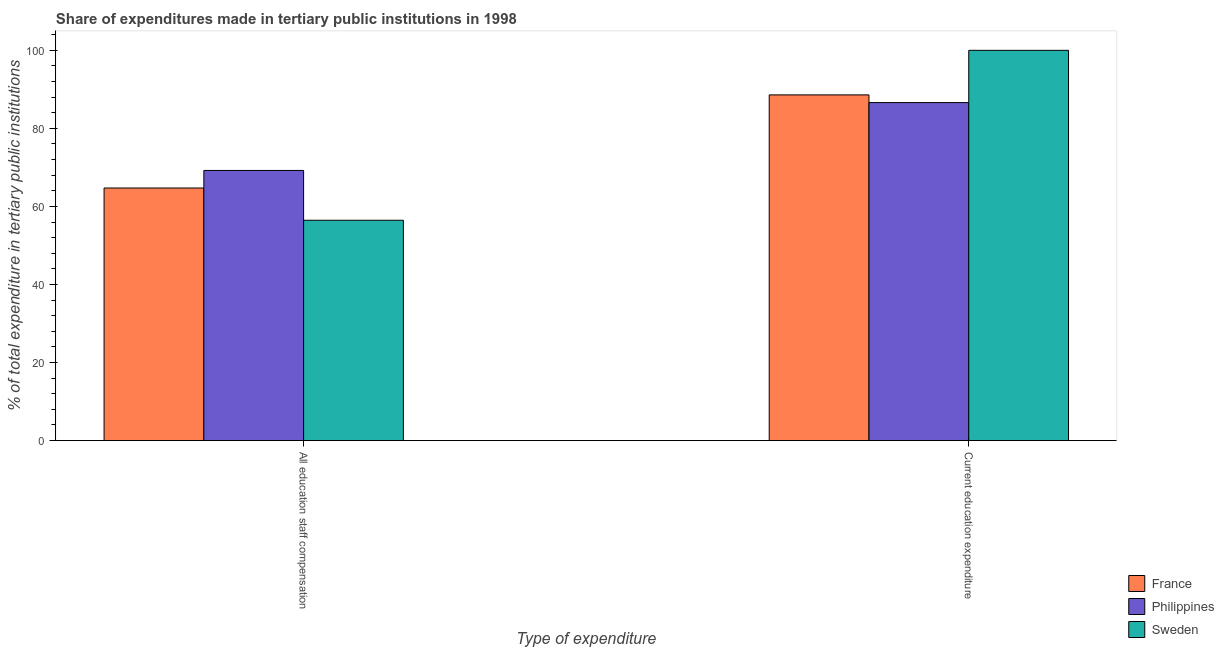How many different coloured bars are there?
Make the answer very short. 3. Are the number of bars per tick equal to the number of legend labels?
Your answer should be very brief. Yes. Are the number of bars on each tick of the X-axis equal?
Your answer should be compact. Yes. How many bars are there on the 2nd tick from the left?
Provide a short and direct response. 3. How many bars are there on the 2nd tick from the right?
Ensure brevity in your answer.  3. What is the label of the 2nd group of bars from the left?
Your answer should be compact. Current education expenditure. What is the expenditure in education in France?
Provide a short and direct response. 88.58. Across all countries, what is the maximum expenditure in staff compensation?
Offer a terse response. 69.22. Across all countries, what is the minimum expenditure in education?
Provide a succinct answer. 86.61. In which country was the expenditure in staff compensation maximum?
Your answer should be compact. Philippines. In which country was the expenditure in staff compensation minimum?
Make the answer very short. Sweden. What is the total expenditure in education in the graph?
Give a very brief answer. 275.19. What is the difference between the expenditure in staff compensation in Sweden and that in France?
Offer a very short reply. -8.26. What is the difference between the expenditure in education in Philippines and the expenditure in staff compensation in France?
Give a very brief answer. 21.89. What is the average expenditure in education per country?
Your answer should be very brief. 91.73. What is the difference between the expenditure in education and expenditure in staff compensation in France?
Make the answer very short. 23.86. In how many countries, is the expenditure in staff compensation greater than 88 %?
Your answer should be compact. 0. What is the ratio of the expenditure in education in Sweden to that in Philippines?
Give a very brief answer. 1.15. What does the 1st bar from the left in All education staff compensation represents?
Ensure brevity in your answer.  France. How many bars are there?
Provide a short and direct response. 6. Are all the bars in the graph horizontal?
Make the answer very short. No. Where does the legend appear in the graph?
Ensure brevity in your answer.  Bottom right. How many legend labels are there?
Give a very brief answer. 3. How are the legend labels stacked?
Your answer should be very brief. Vertical. What is the title of the graph?
Ensure brevity in your answer.  Share of expenditures made in tertiary public institutions in 1998. What is the label or title of the X-axis?
Keep it short and to the point. Type of expenditure. What is the label or title of the Y-axis?
Offer a very short reply. % of total expenditure in tertiary public institutions. What is the % of total expenditure in tertiary public institutions of France in All education staff compensation?
Make the answer very short. 64.72. What is the % of total expenditure in tertiary public institutions of Philippines in All education staff compensation?
Your answer should be very brief. 69.22. What is the % of total expenditure in tertiary public institutions of Sweden in All education staff compensation?
Your answer should be compact. 56.46. What is the % of total expenditure in tertiary public institutions of France in Current education expenditure?
Keep it short and to the point. 88.58. What is the % of total expenditure in tertiary public institutions in Philippines in Current education expenditure?
Give a very brief answer. 86.61. Across all Type of expenditure, what is the maximum % of total expenditure in tertiary public institutions of France?
Provide a succinct answer. 88.58. Across all Type of expenditure, what is the maximum % of total expenditure in tertiary public institutions of Philippines?
Provide a succinct answer. 86.61. Across all Type of expenditure, what is the minimum % of total expenditure in tertiary public institutions in France?
Offer a very short reply. 64.72. Across all Type of expenditure, what is the minimum % of total expenditure in tertiary public institutions of Philippines?
Make the answer very short. 69.22. Across all Type of expenditure, what is the minimum % of total expenditure in tertiary public institutions of Sweden?
Give a very brief answer. 56.46. What is the total % of total expenditure in tertiary public institutions of France in the graph?
Make the answer very short. 153.3. What is the total % of total expenditure in tertiary public institutions of Philippines in the graph?
Your response must be concise. 155.83. What is the total % of total expenditure in tertiary public institutions of Sweden in the graph?
Provide a succinct answer. 156.46. What is the difference between the % of total expenditure in tertiary public institutions of France in All education staff compensation and that in Current education expenditure?
Provide a succinct answer. -23.86. What is the difference between the % of total expenditure in tertiary public institutions in Philippines in All education staff compensation and that in Current education expenditure?
Ensure brevity in your answer.  -17.39. What is the difference between the % of total expenditure in tertiary public institutions in Sweden in All education staff compensation and that in Current education expenditure?
Keep it short and to the point. -43.54. What is the difference between the % of total expenditure in tertiary public institutions in France in All education staff compensation and the % of total expenditure in tertiary public institutions in Philippines in Current education expenditure?
Provide a short and direct response. -21.89. What is the difference between the % of total expenditure in tertiary public institutions of France in All education staff compensation and the % of total expenditure in tertiary public institutions of Sweden in Current education expenditure?
Your answer should be very brief. -35.28. What is the difference between the % of total expenditure in tertiary public institutions in Philippines in All education staff compensation and the % of total expenditure in tertiary public institutions in Sweden in Current education expenditure?
Keep it short and to the point. -30.78. What is the average % of total expenditure in tertiary public institutions of France per Type of expenditure?
Ensure brevity in your answer.  76.65. What is the average % of total expenditure in tertiary public institutions of Philippines per Type of expenditure?
Offer a very short reply. 77.92. What is the average % of total expenditure in tertiary public institutions in Sweden per Type of expenditure?
Provide a succinct answer. 78.23. What is the difference between the % of total expenditure in tertiary public institutions in France and % of total expenditure in tertiary public institutions in Philippines in All education staff compensation?
Keep it short and to the point. -4.5. What is the difference between the % of total expenditure in tertiary public institutions of France and % of total expenditure in tertiary public institutions of Sweden in All education staff compensation?
Give a very brief answer. 8.26. What is the difference between the % of total expenditure in tertiary public institutions of Philippines and % of total expenditure in tertiary public institutions of Sweden in All education staff compensation?
Provide a short and direct response. 12.77. What is the difference between the % of total expenditure in tertiary public institutions of France and % of total expenditure in tertiary public institutions of Philippines in Current education expenditure?
Offer a very short reply. 1.97. What is the difference between the % of total expenditure in tertiary public institutions in France and % of total expenditure in tertiary public institutions in Sweden in Current education expenditure?
Give a very brief answer. -11.42. What is the difference between the % of total expenditure in tertiary public institutions of Philippines and % of total expenditure in tertiary public institutions of Sweden in Current education expenditure?
Provide a short and direct response. -13.39. What is the ratio of the % of total expenditure in tertiary public institutions of France in All education staff compensation to that in Current education expenditure?
Keep it short and to the point. 0.73. What is the ratio of the % of total expenditure in tertiary public institutions in Philippines in All education staff compensation to that in Current education expenditure?
Give a very brief answer. 0.8. What is the ratio of the % of total expenditure in tertiary public institutions in Sweden in All education staff compensation to that in Current education expenditure?
Keep it short and to the point. 0.56. What is the difference between the highest and the second highest % of total expenditure in tertiary public institutions in France?
Ensure brevity in your answer.  23.86. What is the difference between the highest and the second highest % of total expenditure in tertiary public institutions in Philippines?
Offer a terse response. 17.39. What is the difference between the highest and the second highest % of total expenditure in tertiary public institutions in Sweden?
Offer a very short reply. 43.54. What is the difference between the highest and the lowest % of total expenditure in tertiary public institutions of France?
Provide a short and direct response. 23.86. What is the difference between the highest and the lowest % of total expenditure in tertiary public institutions of Philippines?
Your response must be concise. 17.39. What is the difference between the highest and the lowest % of total expenditure in tertiary public institutions of Sweden?
Provide a short and direct response. 43.54. 